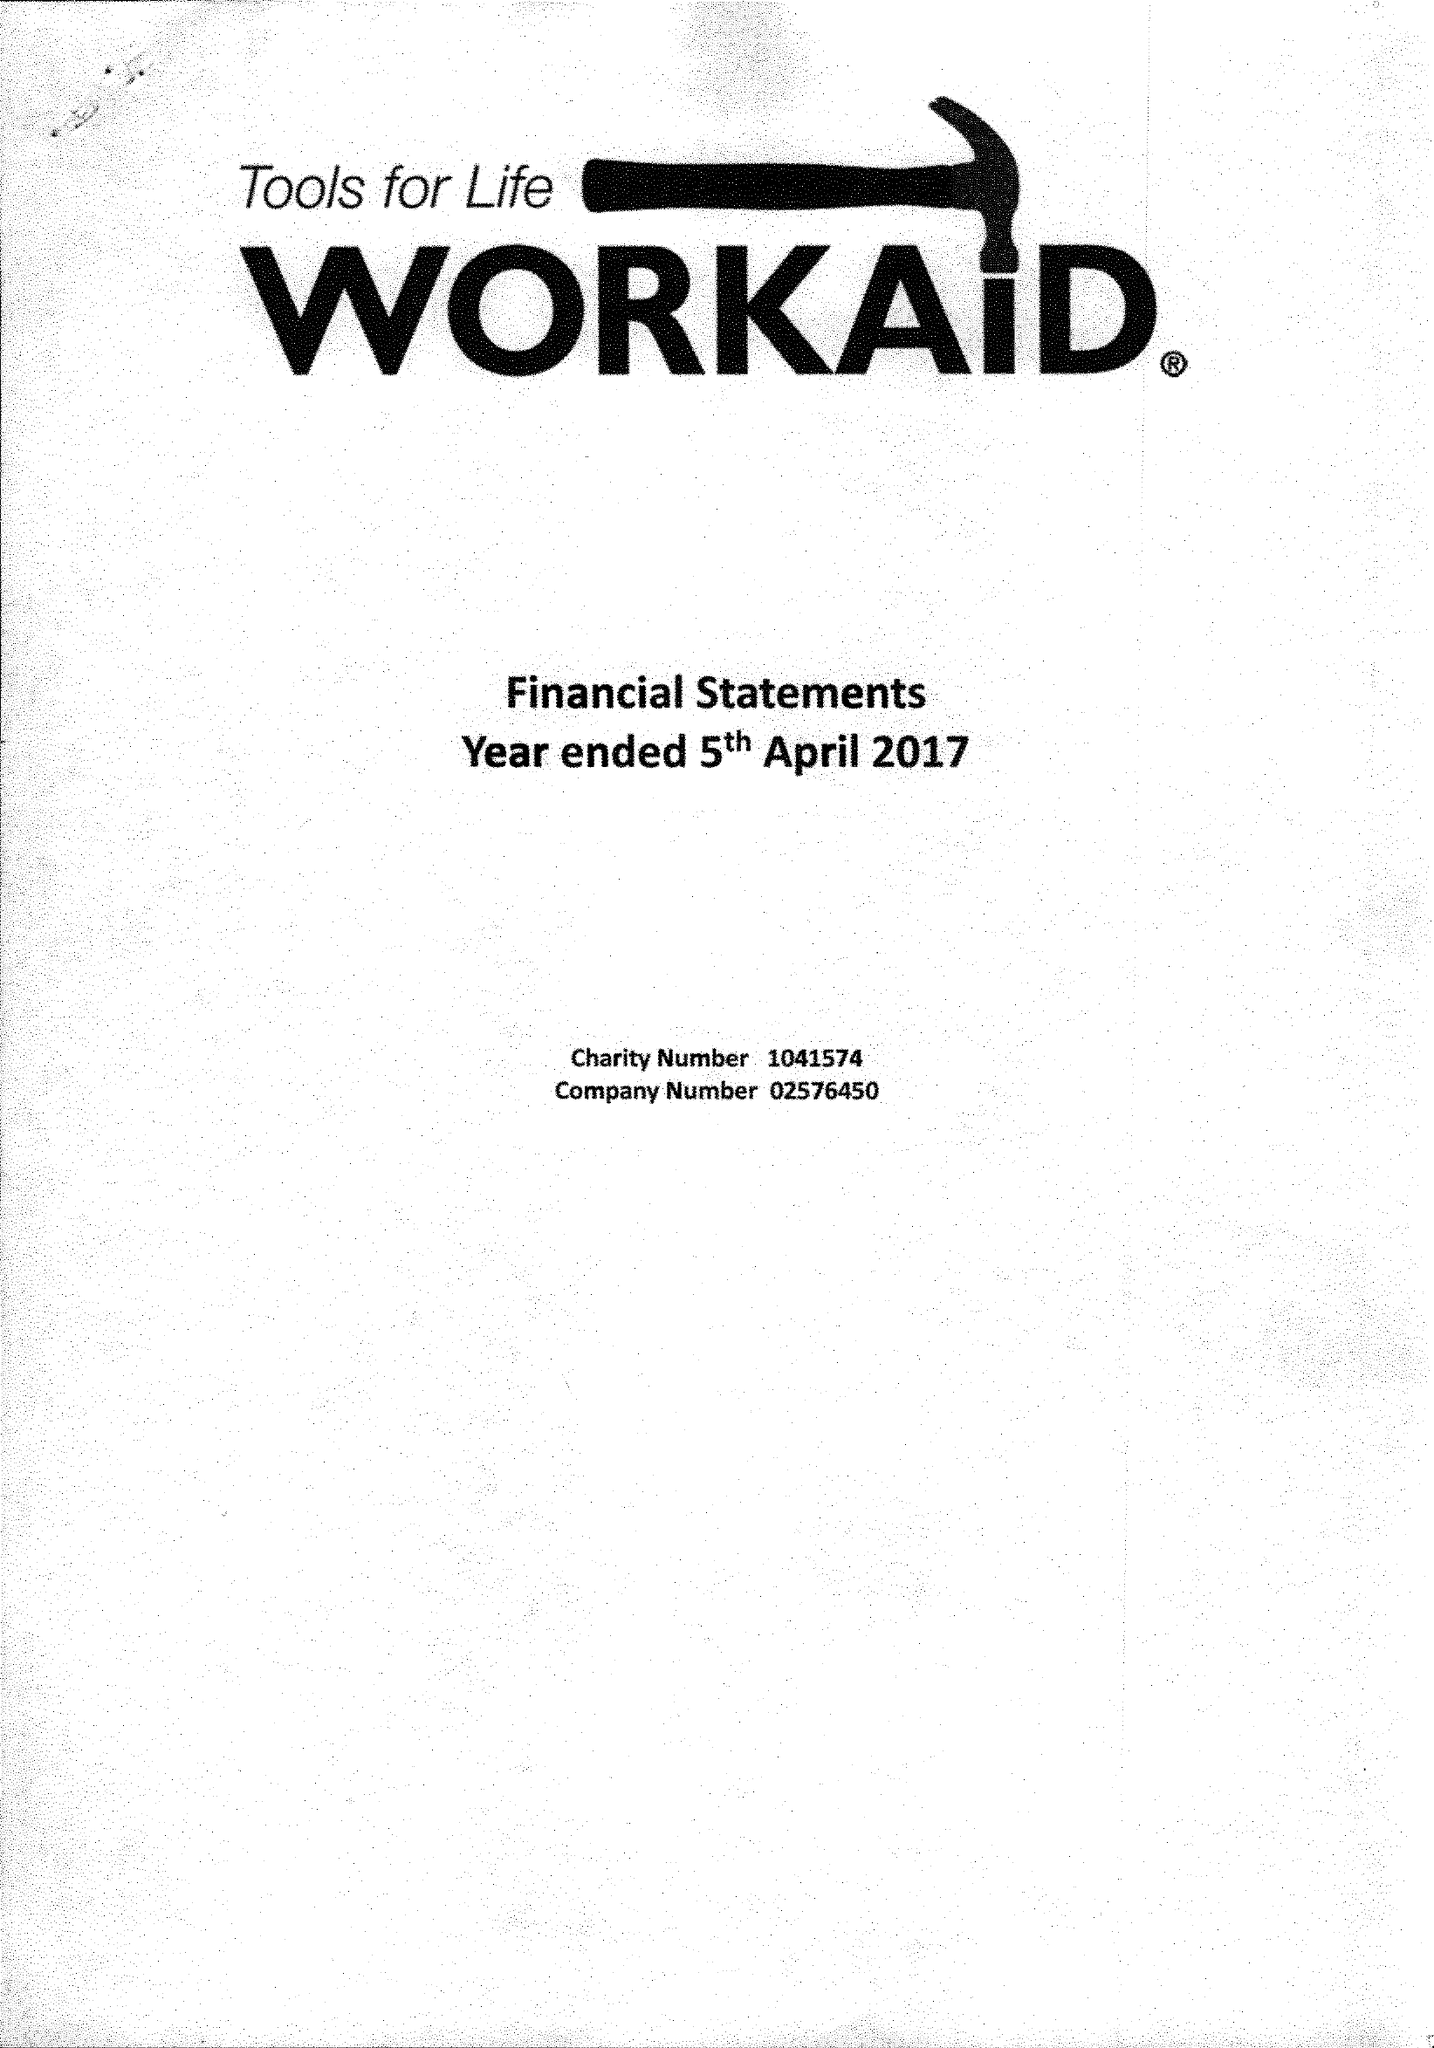What is the value for the address__street_line?
Answer the question using a single word or phrase. 71 TOWNSEND ROAD 